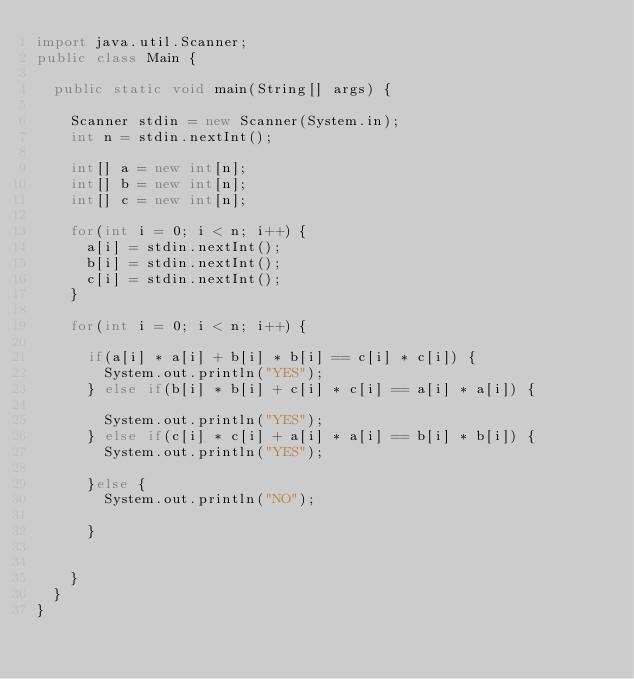<code> <loc_0><loc_0><loc_500><loc_500><_Java_>import java.util.Scanner;
public class Main {

	public static void main(String[] args) {

		Scanner stdin = new Scanner(System.in);
		int n = stdin.nextInt();

		int[] a = new int[n];
		int[] b = new int[n];
		int[] c = new int[n];

		for(int i = 0; i < n; i++) {
			a[i] = stdin.nextInt();
			b[i] = stdin.nextInt();
			c[i] = stdin.nextInt();
		}

		for(int i = 0; i < n; i++) {

			if(a[i] * a[i] + b[i] * b[i] == c[i] * c[i]) {
				System.out.println("YES");
			} else if(b[i] * b[i] + c[i] * c[i] == a[i] * a[i]) {

				System.out.println("YES");
			} else if(c[i] * c[i] + a[i] * a[i] == b[i] * b[i]) {
				System.out.println("YES");

			}else {
				System.out.println("NO");

			}


		}
	}
}</code> 